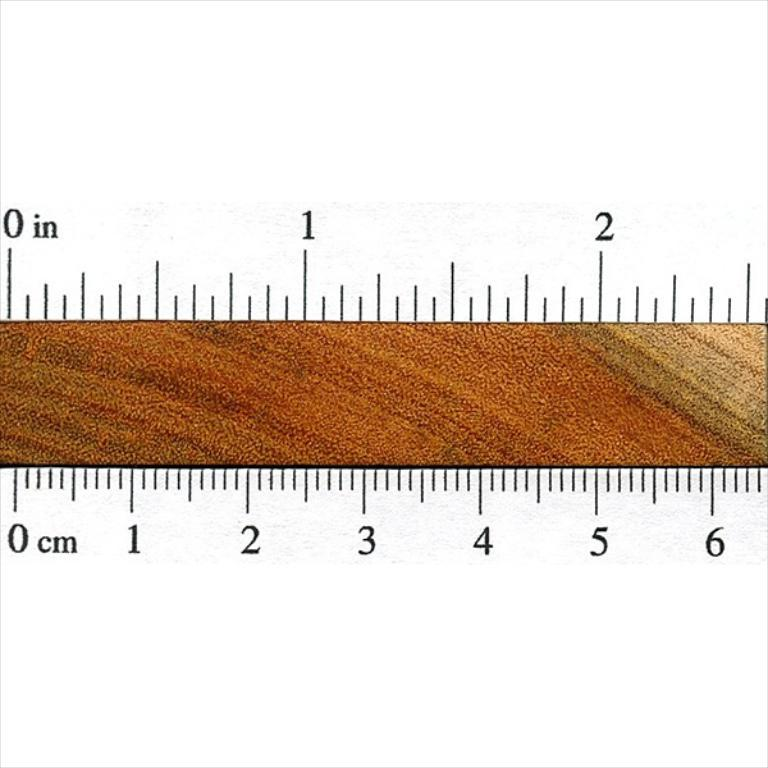<image>
Summarize the visual content of the image. A brown colored strip has inch and cm scale lines on both sides. 